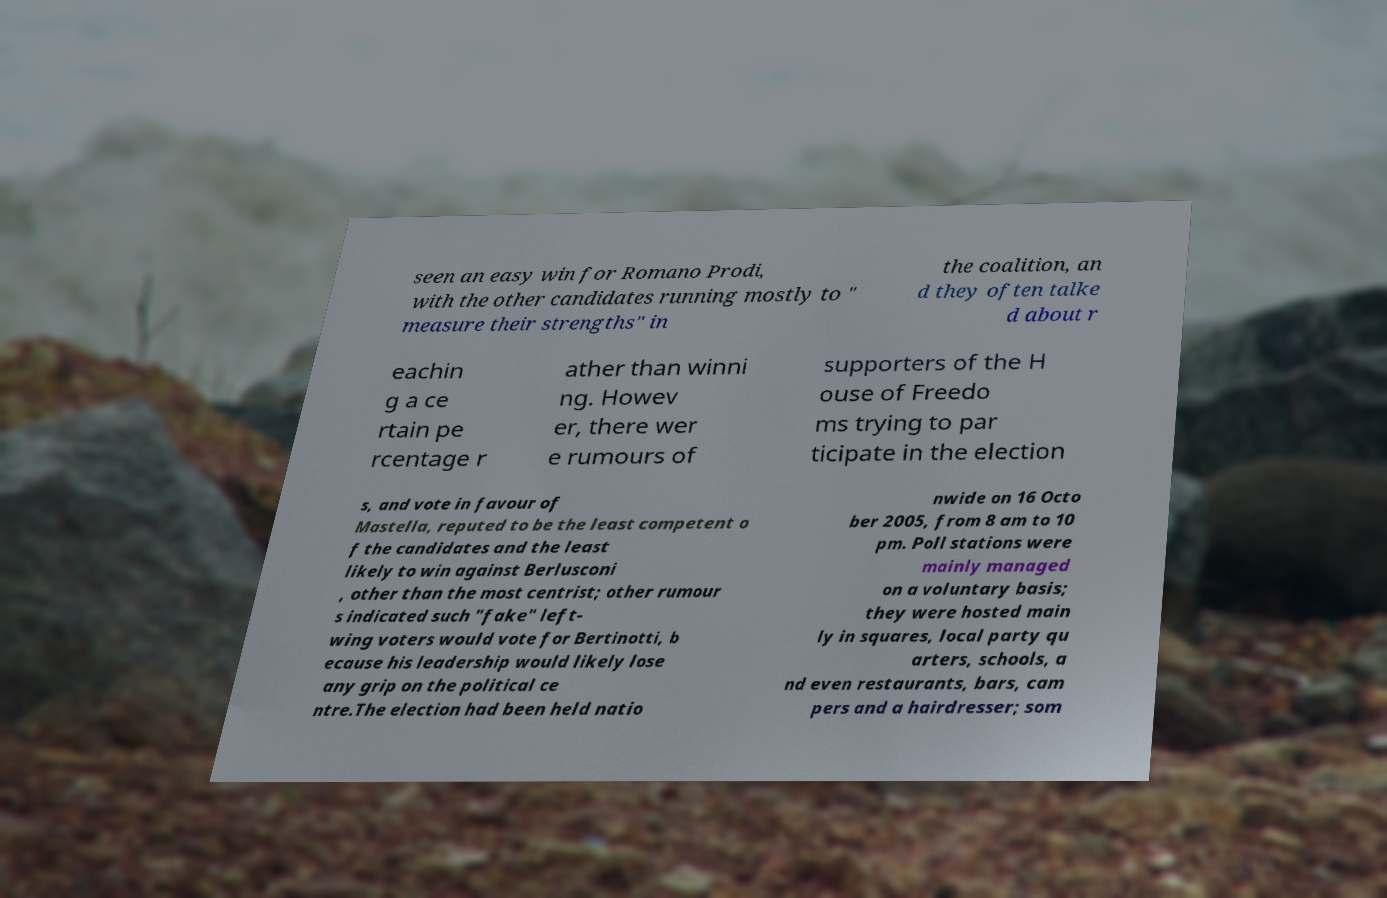There's text embedded in this image that I need extracted. Can you transcribe it verbatim? seen an easy win for Romano Prodi, with the other candidates running mostly to " measure their strengths" in the coalition, an d they often talke d about r eachin g a ce rtain pe rcentage r ather than winni ng. Howev er, there wer e rumours of supporters of the H ouse of Freedo ms trying to par ticipate in the election s, and vote in favour of Mastella, reputed to be the least competent o f the candidates and the least likely to win against Berlusconi , other than the most centrist; other rumour s indicated such "fake" left- wing voters would vote for Bertinotti, b ecause his leadership would likely lose any grip on the political ce ntre.The election had been held natio nwide on 16 Octo ber 2005, from 8 am to 10 pm. Poll stations were mainly managed on a voluntary basis; they were hosted main ly in squares, local party qu arters, schools, a nd even restaurants, bars, cam pers and a hairdresser; som 